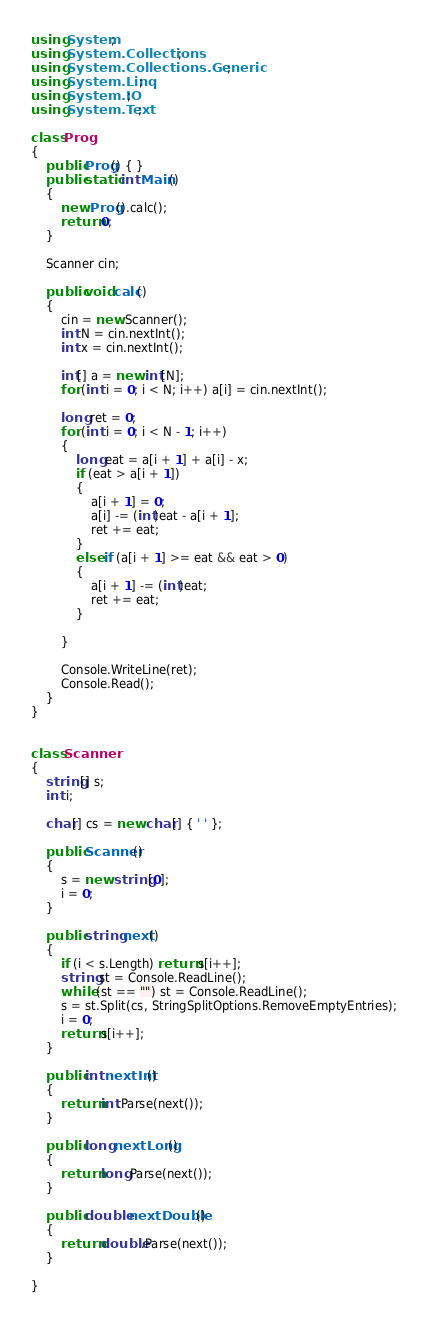Convert code to text. <code><loc_0><loc_0><loc_500><loc_500><_C#_>using System;
using System.Collections;
using System.Collections.Generic;
using System.Linq;
using System.IO;
using System.Text;

class Prog
{
    public Prog() { }
    public static int Main()
    {
        new Prog().calc();
        return 0;
    }

    Scanner cin;

    public void calc()
    {
        cin = new Scanner();
        int N = cin.nextInt();
        int x = cin.nextInt();

        int[] a = new int[N];
        for (int i = 0; i < N; i++) a[i] = cin.nextInt();

        long ret = 0;
        for (int i = 0; i < N - 1; i++)
        {
            long eat = a[i + 1] + a[i] - x;
            if (eat > a[i + 1])
            {
                a[i + 1] = 0;
                a[i] -= (int)eat - a[i + 1];
                ret += eat;
            }
            else if (a[i + 1] >= eat && eat > 0)
            {
                a[i + 1] -= (int)eat;
                ret += eat;
            }
            
        }

        Console.WriteLine(ret);
        Console.Read();
    }
}


class Scanner
{
    string[] s;
    int i;

    char[] cs = new char[] { ' ' };

    public Scanner()
    {
        s = new string[0];
        i = 0;
    }

    public string next()
    {
        if (i < s.Length) return s[i++];
        string st = Console.ReadLine();
        while (st == "") st = Console.ReadLine();
        s = st.Split(cs, StringSplitOptions.RemoveEmptyEntries);
        i = 0;
        return s[i++];
    }

    public int nextInt()
    {
        return int.Parse(next());
    }

    public long nextLong()
    {
        return long.Parse(next());
    }

    public double nextDouble()  
    {
        return double.Parse(next());
    }

}</code> 